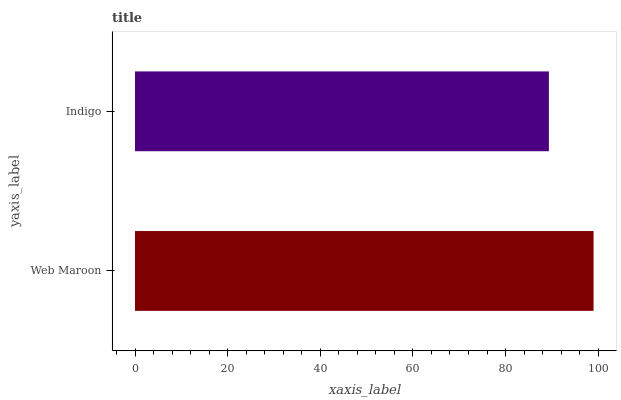Is Indigo the minimum?
Answer yes or no. Yes. Is Web Maroon the maximum?
Answer yes or no. Yes. Is Indigo the maximum?
Answer yes or no. No. Is Web Maroon greater than Indigo?
Answer yes or no. Yes. Is Indigo less than Web Maroon?
Answer yes or no. Yes. Is Indigo greater than Web Maroon?
Answer yes or no. No. Is Web Maroon less than Indigo?
Answer yes or no. No. Is Web Maroon the high median?
Answer yes or no. Yes. Is Indigo the low median?
Answer yes or no. Yes. Is Indigo the high median?
Answer yes or no. No. Is Web Maroon the low median?
Answer yes or no. No. 